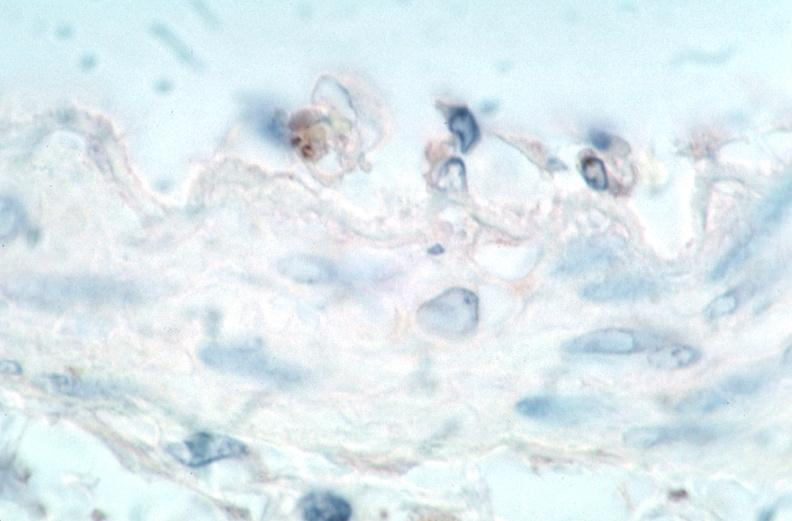s rocky mountain spotted fever, immunoperoxidase staining vessels for rickettsia rickettsii?
Answer the question using a single word or phrase. Yes 